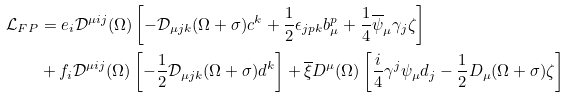<formula> <loc_0><loc_0><loc_500><loc_500>\mathcal { L } _ { F P } & = e _ { i } \mathcal { D } ^ { \mu i j } ( \Omega ) \left [ - \mathcal { D } _ { \mu j k } ( \Omega + \sigma ) c ^ { k } + \frac { 1 } { 2 } \epsilon _ { j p k } b _ { \mu } ^ { p } + \frac { 1 } { 4 } \overline { \psi } _ { \mu } \gamma _ { j } \zeta \right ] \\ & + f _ { i } \mathcal { D } ^ { \mu i j } ( \Omega ) \left [ - \frac { 1 } { 2 } \mathcal { D } _ { \mu j k } ( \Omega + \sigma ) d ^ { k } \right ] + \overline { \xi } D ^ { \mu } ( \Omega ) \left [ \frac { i } { 4 } \gamma ^ { j } \psi _ { \mu } d _ { j } - \frac { 1 } { 2 } D _ { \mu } ( \Omega + \sigma ) \zeta \right ]</formula> 